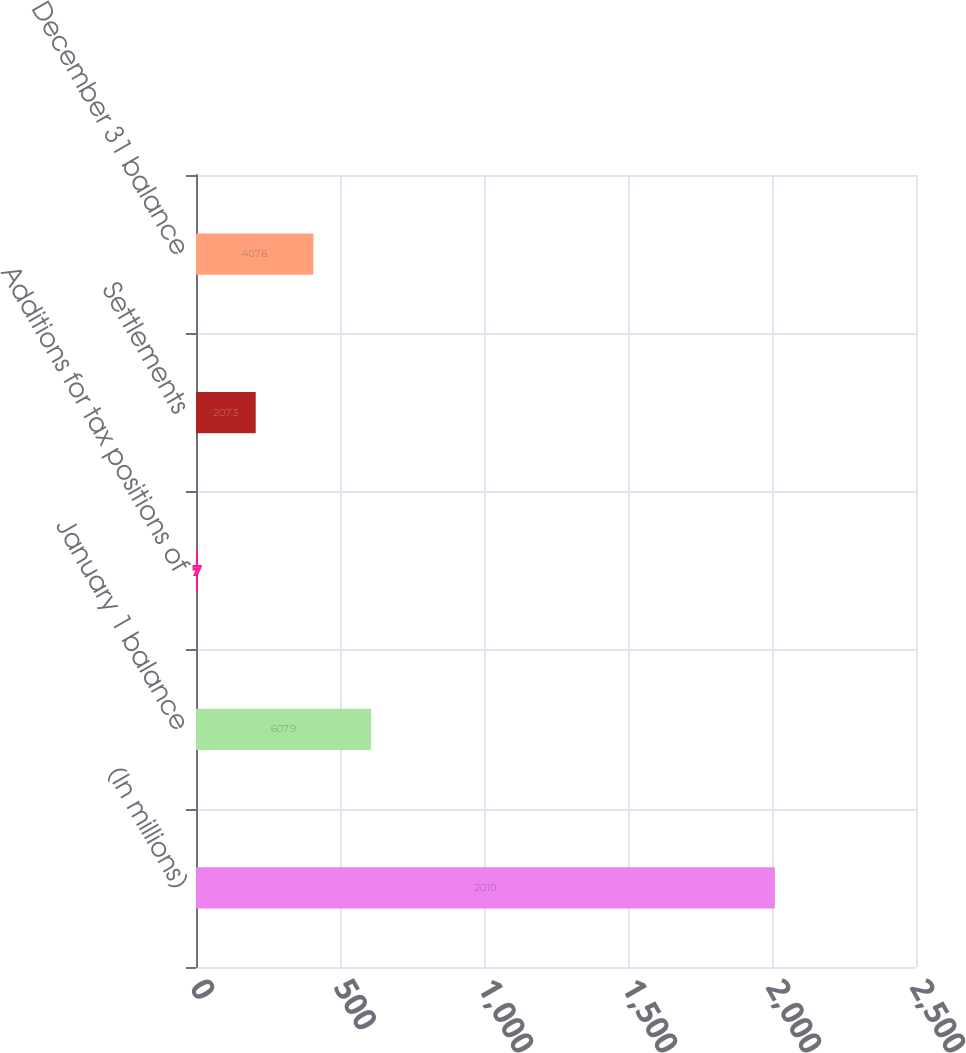<chart> <loc_0><loc_0><loc_500><loc_500><bar_chart><fcel>(In millions)<fcel>January 1 balance<fcel>Additions for tax positions of<fcel>Settlements<fcel>December 31 balance<nl><fcel>2010<fcel>607.9<fcel>7<fcel>207.3<fcel>407.6<nl></chart> 